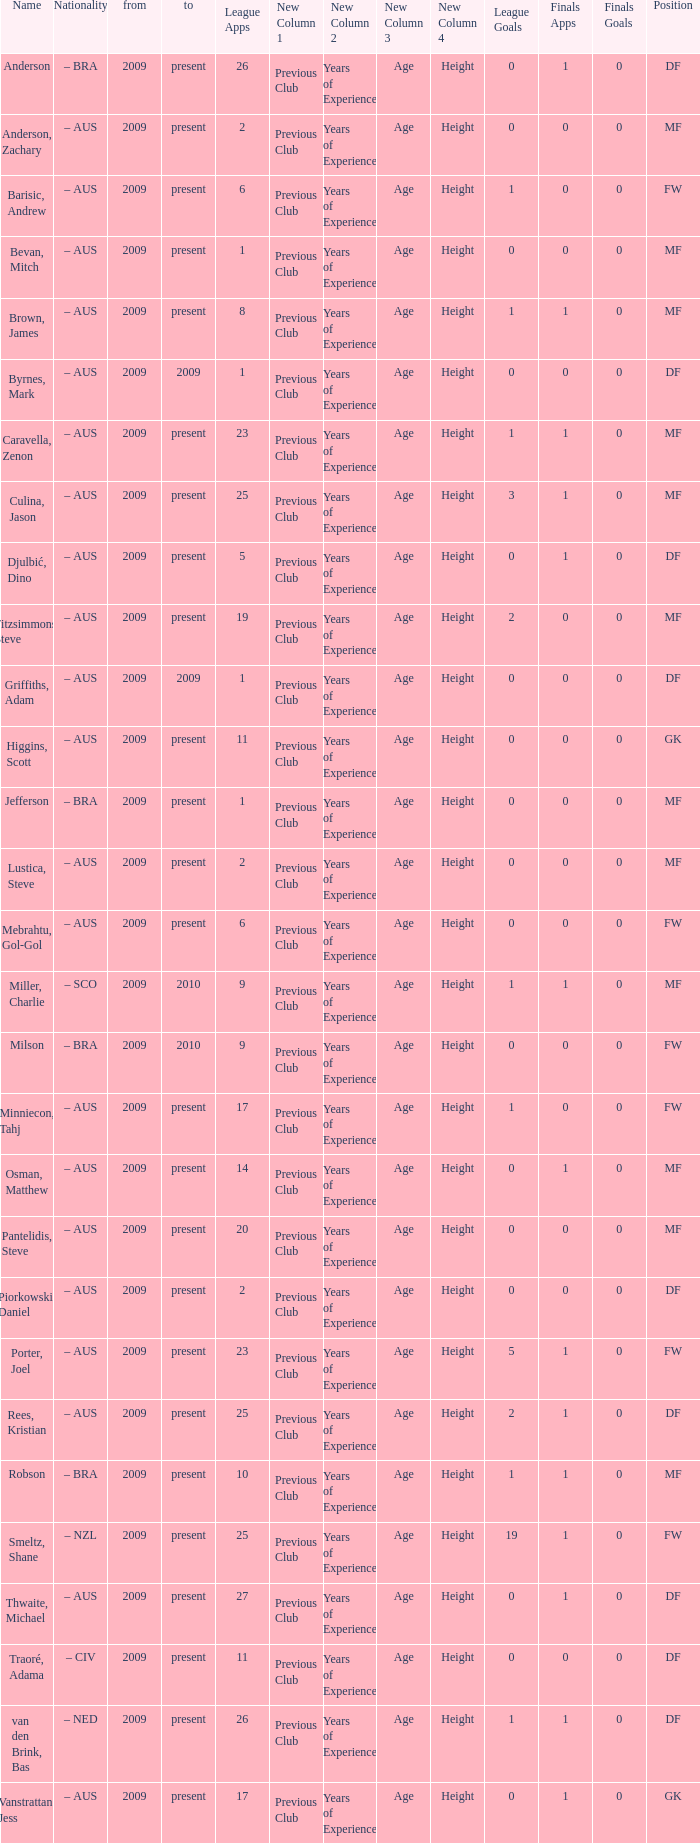Name the to for 19 league apps Present. Could you help me parse every detail presented in this table? {'header': ['Name', 'Nationality', 'from', 'to', 'League Apps', 'New Column 1', 'New Column 2', 'New Column 3', 'New Column 4', 'League Goals', 'Finals Apps', 'Finals Goals', 'Position'], 'rows': [['Anderson', '– BRA', '2009', 'present', '26', 'Previous Club', 'Years of Experience', 'Age', 'Height', '0', '1', '0', 'DF'], ['Anderson, Zachary', '– AUS', '2009', 'present', '2', 'Previous Club', 'Years of Experience', 'Age', 'Height', '0', '0', '0', 'MF'], ['Barisic, Andrew', '– AUS', '2009', 'present', '6', 'Previous Club', 'Years of Experience', 'Age', 'Height', '1', '0', '0', 'FW'], ['Bevan, Mitch', '– AUS', '2009', 'present', '1', 'Previous Club', 'Years of Experience', 'Age', 'Height', '0', '0', '0', 'MF'], ['Brown, James', '– AUS', '2009', 'present', '8', 'Previous Club', 'Years of Experience', 'Age', 'Height', '1', '1', '0', 'MF'], ['Byrnes, Mark', '– AUS', '2009', '2009', '1', 'Previous Club', 'Years of Experience', 'Age', 'Height', '0', '0', '0', 'DF'], ['Caravella, Zenon', '– AUS', '2009', 'present', '23', 'Previous Club', 'Years of Experience', 'Age', 'Height', '1', '1', '0', 'MF'], ['Culina, Jason', '– AUS', '2009', 'present', '25', 'Previous Club', 'Years of Experience', 'Age', 'Height', '3', '1', '0', 'MF'], ['Djulbić, Dino', '– AUS', '2009', 'present', '5', 'Previous Club', 'Years of Experience', 'Age', 'Height', '0', '1', '0', 'DF'], ['Fitzsimmons, Steve', '– AUS', '2009', 'present', '19', 'Previous Club', 'Years of Experience', 'Age', 'Height', '2', '0', '0', 'MF'], ['Griffiths, Adam', '– AUS', '2009', '2009', '1', 'Previous Club', 'Years of Experience', 'Age', 'Height', '0', '0', '0', 'DF'], ['Higgins, Scott', '– AUS', '2009', 'present', '11', 'Previous Club', 'Years of Experience', 'Age', 'Height', '0', '0', '0', 'GK'], ['Jefferson', '– BRA', '2009', 'present', '1', 'Previous Club', 'Years of Experience', 'Age', 'Height', '0', '0', '0', 'MF'], ['Lustica, Steve', '– AUS', '2009', 'present', '2', 'Previous Club', 'Years of Experience', 'Age', 'Height', '0', '0', '0', 'MF'], ['Mebrahtu, Gol-Gol', '– AUS', '2009', 'present', '6', 'Previous Club', 'Years of Experience', 'Age', 'Height', '0', '0', '0', 'FW'], ['Miller, Charlie', '– SCO', '2009', '2010', '9', 'Previous Club', 'Years of Experience', 'Age', 'Height', '1', '1', '0', 'MF'], ['Milson', '– BRA', '2009', '2010', '9', 'Previous Club', 'Years of Experience', 'Age', 'Height', '0', '0', '0', 'FW'], ['Minniecon, Tahj', '– AUS', '2009', 'present', '17', 'Previous Club', 'Years of Experience', 'Age', 'Height', '1', '0', '0', 'FW'], ['Osman, Matthew', '– AUS', '2009', 'present', '14', 'Previous Club', 'Years of Experience', 'Age', 'Height', '0', '1', '0', 'MF'], ['Pantelidis, Steve', '– AUS', '2009', 'present', '20', 'Previous Club', 'Years of Experience', 'Age', 'Height', '0', '0', '0', 'MF'], ['Piorkowski, Daniel', '– AUS', '2009', 'present', '2', 'Previous Club', 'Years of Experience', 'Age', 'Height', '0', '0', '0', 'DF'], ['Porter, Joel', '– AUS', '2009', 'present', '23', 'Previous Club', 'Years of Experience', 'Age', 'Height', '5', '1', '0', 'FW'], ['Rees, Kristian', '– AUS', '2009', 'present', '25', 'Previous Club', 'Years of Experience', 'Age', 'Height', '2', '1', '0', 'DF'], ['Robson', '– BRA', '2009', 'present', '10', 'Previous Club', 'Years of Experience', 'Age', 'Height', '1', '1', '0', 'MF'], ['Smeltz, Shane', '– NZL', '2009', 'present', '25', 'Previous Club', 'Years of Experience', 'Age', 'Height', '19', '1', '0', 'FW'], ['Thwaite, Michael', '– AUS', '2009', 'present', '27', 'Previous Club', 'Years of Experience', 'Age', 'Height', '0', '1', '0', 'DF'], ['Traoré, Adama', '– CIV', '2009', 'present', '11', 'Previous Club', 'Years of Experience', 'Age', 'Height', '0', '0', '0', 'DF'], ['van den Brink, Bas', '– NED', '2009', 'present', '26', 'Previous Club', 'Years of Experience', 'Age', 'Height', '1', '1', '0', 'DF'], ['Vanstrattan, Jess', '– AUS', '2009', 'present', '17', 'Previous Club', 'Years of Experience', 'Age', 'Height', '0', '1', '0', 'GK']]} 